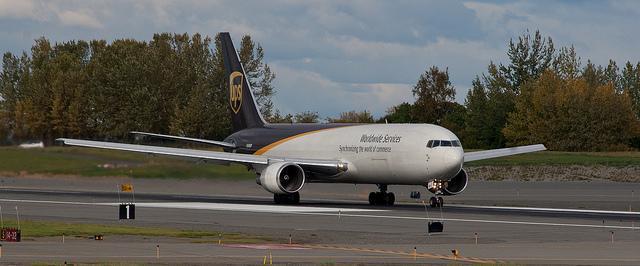How many windows are here?
Give a very brief answer. 4. How many zebras are in the picture?
Give a very brief answer. 0. 